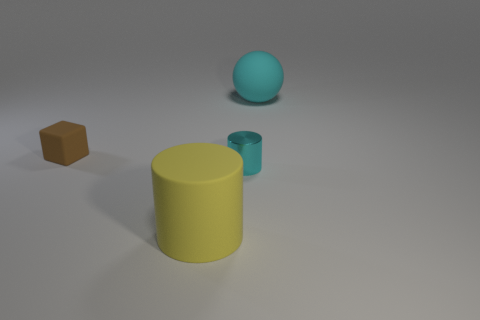What is the size of the thing that is the same color as the small cylinder?
Keep it short and to the point. Large. There is a cyan object that is in front of the tiny thing behind the small cylinder; what number of small things are behind it?
Make the answer very short. 1. Does the matte ball have the same size as the cyan thing in front of the cube?
Make the answer very short. No. There is a cyan object that is in front of the brown block that is to the left of the cyan shiny thing; what is its size?
Ensure brevity in your answer.  Small. What number of other cyan cylinders are made of the same material as the big cylinder?
Provide a short and direct response. 0. Is there a big cyan ball?
Ensure brevity in your answer.  Yes. There is a cylinder that is behind the large yellow cylinder; what size is it?
Ensure brevity in your answer.  Small. How many other big things have the same color as the metallic object?
Provide a short and direct response. 1. How many cylinders are yellow objects or large cyan matte things?
Your answer should be very brief. 1. There is a matte object that is both to the left of the big cyan ball and behind the yellow matte cylinder; what is its shape?
Give a very brief answer. Cube. 